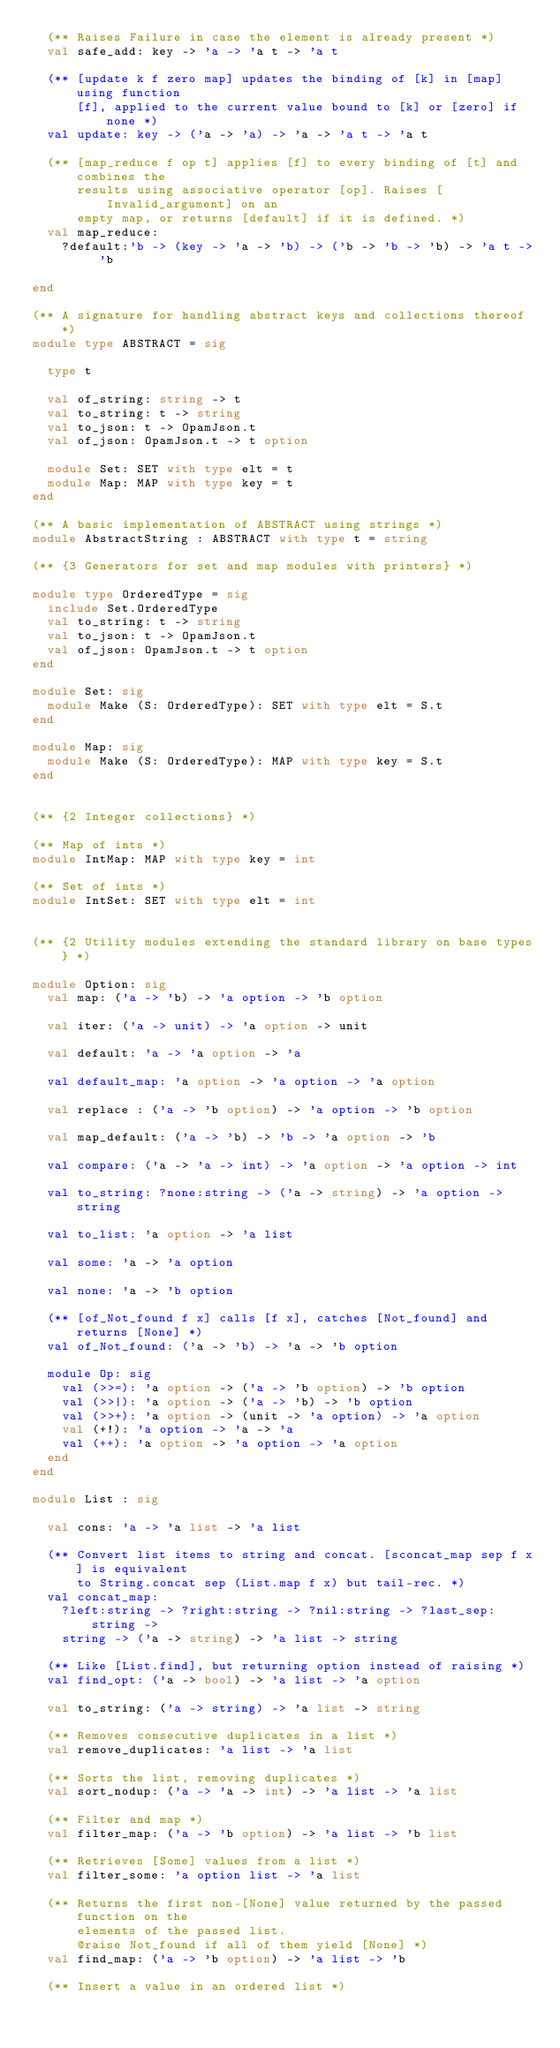Convert code to text. <code><loc_0><loc_0><loc_500><loc_500><_OCaml_>  (** Raises Failure in case the element is already present *)
  val safe_add: key -> 'a -> 'a t -> 'a t

  (** [update k f zero map] updates the binding of [k] in [map] using function
      [f], applied to the current value bound to [k] or [zero] if none *)
  val update: key -> ('a -> 'a) -> 'a -> 'a t -> 'a t

  (** [map_reduce f op t] applies [f] to every binding of [t] and combines the
      results using associative operator [op]. Raises [Invalid_argument] on an
      empty map, or returns [default] if it is defined. *)
  val map_reduce:
    ?default:'b -> (key -> 'a -> 'b) -> ('b -> 'b -> 'b) -> 'a t -> 'b

end

(** A signature for handling abstract keys and collections thereof *)
module type ABSTRACT = sig

  type t

  val of_string: string -> t
  val to_string: t -> string
  val to_json: t -> OpamJson.t
  val of_json: OpamJson.t -> t option

  module Set: SET with type elt = t
  module Map: MAP with type key = t
end

(** A basic implementation of ABSTRACT using strings *)
module AbstractString : ABSTRACT with type t = string

(** {3 Generators for set and map modules with printers} *)

module type OrderedType = sig
  include Set.OrderedType
  val to_string: t -> string
  val to_json: t -> OpamJson.t
  val of_json: OpamJson.t -> t option
end

module Set: sig
  module Make (S: OrderedType): SET with type elt = S.t
end

module Map: sig
  module Make (S: OrderedType): MAP with type key = S.t
end


(** {2 Integer collections} *)

(** Map of ints *)
module IntMap: MAP with type key = int

(** Set of ints *)
module IntSet: SET with type elt = int


(** {2 Utility modules extending the standard library on base types} *)

module Option: sig
  val map: ('a -> 'b) -> 'a option -> 'b option

  val iter: ('a -> unit) -> 'a option -> unit

  val default: 'a -> 'a option -> 'a

  val default_map: 'a option -> 'a option -> 'a option

  val replace : ('a -> 'b option) -> 'a option -> 'b option

  val map_default: ('a -> 'b) -> 'b -> 'a option -> 'b

  val compare: ('a -> 'a -> int) -> 'a option -> 'a option -> int

  val to_string: ?none:string -> ('a -> string) -> 'a option -> string

  val to_list: 'a option -> 'a list

  val some: 'a -> 'a option

  val none: 'a -> 'b option

  (** [of_Not_found f x] calls [f x], catches [Not_found] and returns [None] *)
  val of_Not_found: ('a -> 'b) -> 'a -> 'b option

  module Op: sig
    val (>>=): 'a option -> ('a -> 'b option) -> 'b option
    val (>>|): 'a option -> ('a -> 'b) -> 'b option
    val (>>+): 'a option -> (unit -> 'a option) -> 'a option
    val (+!): 'a option -> 'a -> 'a
    val (++): 'a option -> 'a option -> 'a option
  end
end

module List : sig

  val cons: 'a -> 'a list -> 'a list

  (** Convert list items to string and concat. [sconcat_map sep f x] is equivalent
      to String.concat sep (List.map f x) but tail-rec. *)
  val concat_map:
    ?left:string -> ?right:string -> ?nil:string -> ?last_sep:string ->
    string -> ('a -> string) -> 'a list -> string

  (** Like [List.find], but returning option instead of raising *)
  val find_opt: ('a -> bool) -> 'a list -> 'a option

  val to_string: ('a -> string) -> 'a list -> string

  (** Removes consecutive duplicates in a list *)
  val remove_duplicates: 'a list -> 'a list

  (** Sorts the list, removing duplicates *)
  val sort_nodup: ('a -> 'a -> int) -> 'a list -> 'a list

  (** Filter and map *)
  val filter_map: ('a -> 'b option) -> 'a list -> 'b list

  (** Retrieves [Some] values from a list *)
  val filter_some: 'a option list -> 'a list

  (** Returns the first non-[None] value returned by the passed function on the
      elements of the passed list.
      @raise Not_found if all of them yield [None] *)
  val find_map: ('a -> 'b option) -> 'a list -> 'b

  (** Insert a value in an ordered list *)</code> 